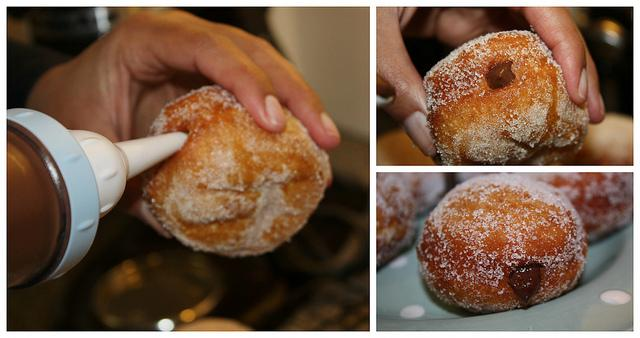What does the container hold? jelly 